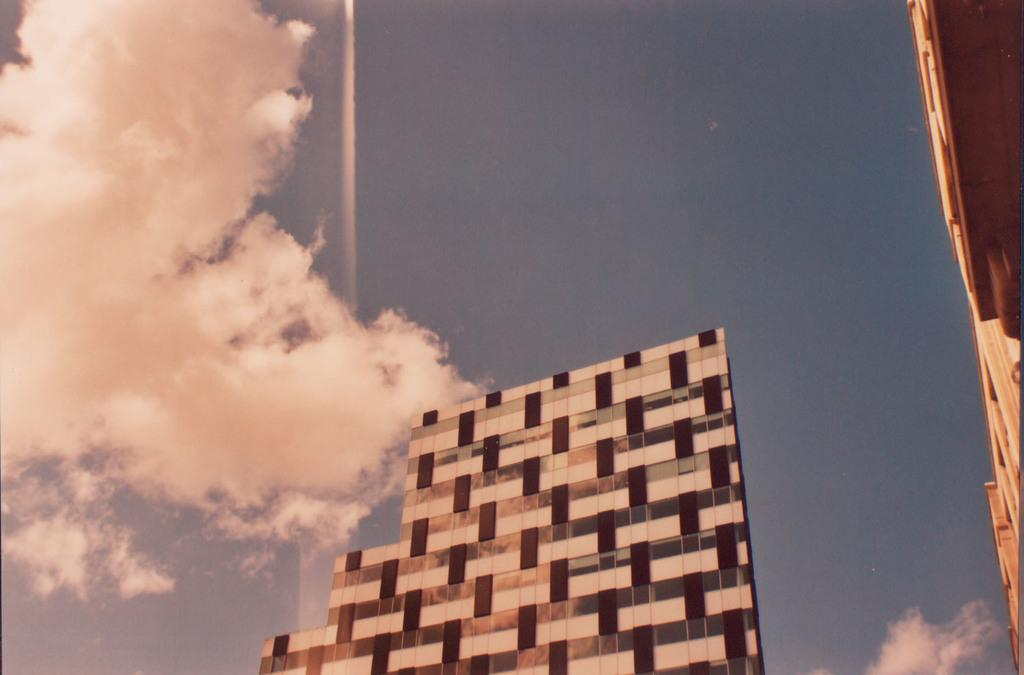What type of structures can be seen in the image? There are buildings in the image. What part of the natural environment is visible in the image? The sky is visible in the image. What can be seen in the sky in the image? There are clouds in the sky. Can you tell me how many crackers are floating in the sky in the image? There are no crackers present in the image; only buildings, sky, and clouds are visible. Is the cook visible in the image? There is no cook present in the image. 